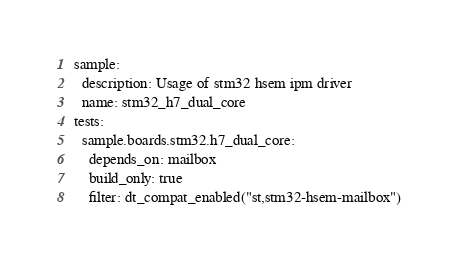Convert code to text. <code><loc_0><loc_0><loc_500><loc_500><_YAML_>sample:
  description: Usage of stm32 hsem ipm driver
  name: stm32_h7_dual_core
tests:
  sample.boards.stm32.h7_dual_core:
    depends_on: mailbox
    build_only: true
    filter: dt_compat_enabled("st,stm32-hsem-mailbox")
</code> 